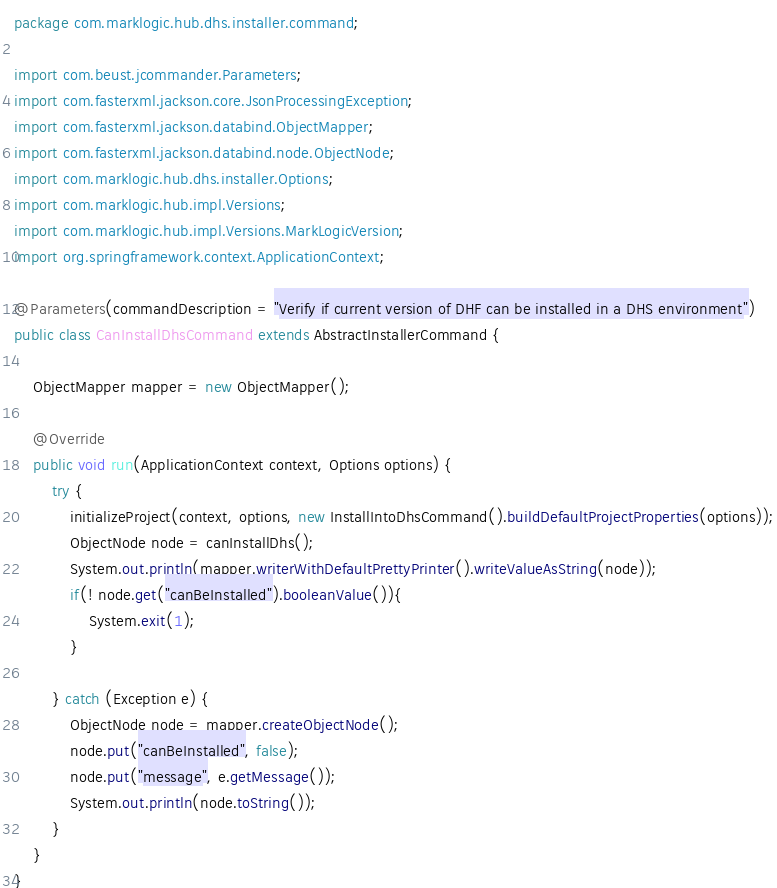Convert code to text. <code><loc_0><loc_0><loc_500><loc_500><_Java_>package com.marklogic.hub.dhs.installer.command;

import com.beust.jcommander.Parameters;
import com.fasterxml.jackson.core.JsonProcessingException;
import com.fasterxml.jackson.databind.ObjectMapper;
import com.fasterxml.jackson.databind.node.ObjectNode;
import com.marklogic.hub.dhs.installer.Options;
import com.marklogic.hub.impl.Versions;
import com.marklogic.hub.impl.Versions.MarkLogicVersion;
import org.springframework.context.ApplicationContext;

@Parameters(commandDescription = "Verify if current version of DHF can be installed in a DHS environment")
public class CanInstallDhsCommand extends AbstractInstallerCommand {

    ObjectMapper mapper = new ObjectMapper();

    @Override
    public void run(ApplicationContext context, Options options) {
        try {
            initializeProject(context, options, new InstallIntoDhsCommand().buildDefaultProjectProperties(options));
            ObjectNode node = canInstallDhs();
            System.out.println(mapper.writerWithDefaultPrettyPrinter().writeValueAsString(node));
            if(! node.get("canBeInstalled").booleanValue()){
                System.exit(1);
            }

        } catch (Exception e) {
            ObjectNode node = mapper.createObjectNode();
            node.put("canBeInstalled", false);
            node.put("message", e.getMessage());
            System.out.println(node.toString());
        }
    }
}
</code> 